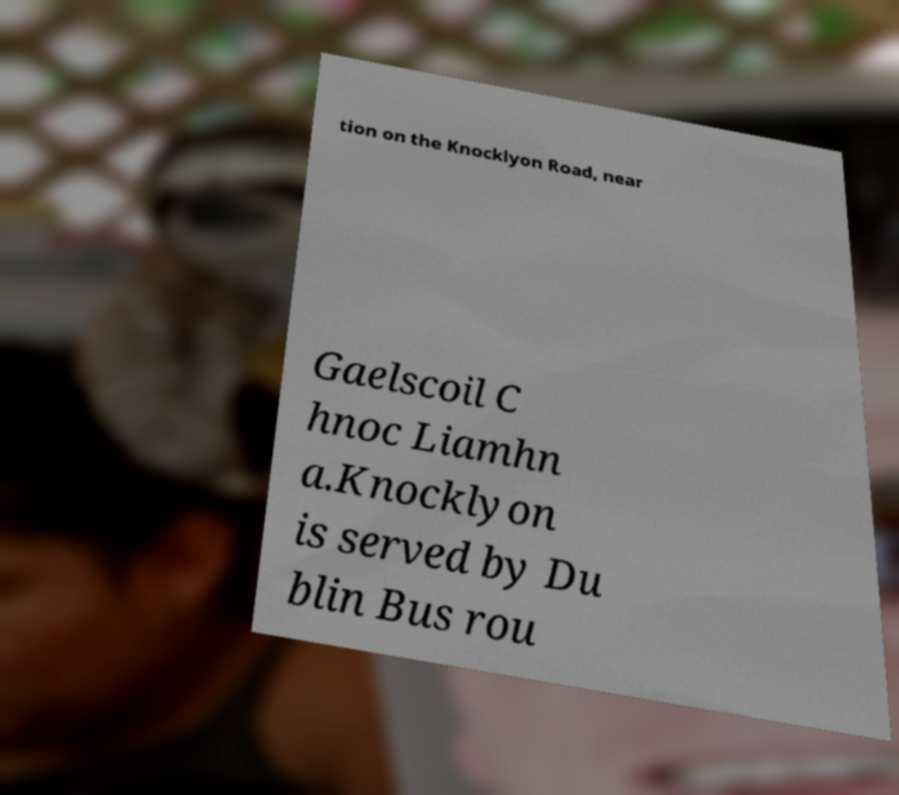I need the written content from this picture converted into text. Can you do that? tion on the Knocklyon Road, near Gaelscoil C hnoc Liamhn a.Knocklyon is served by Du blin Bus rou 